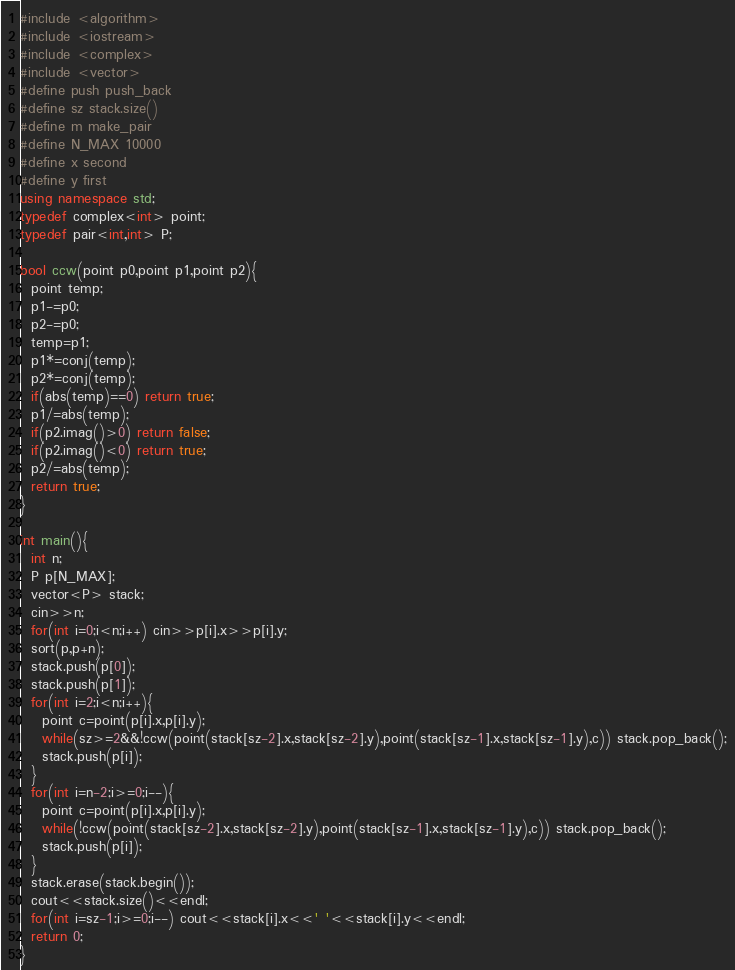Convert code to text. <code><loc_0><loc_0><loc_500><loc_500><_C++_>#include <algorithm>
#include <iostream>
#include <complex>
#include <vector>
#define push push_back
#define sz stack.size()
#define m make_pair
#define N_MAX 10000
#define x second
#define y first
using namespace std;
typedef complex<int> point;
typedef pair<int,int> P;
 
bool ccw(point p0,point p1,point p2){
  point temp;
  p1-=p0;
  p2-=p0;
  temp=p1;
  p1*=conj(temp);
  p2*=conj(temp);
  if(abs(temp)==0) return true;
  p1/=abs(temp);
  if(p2.imag()>0) return false;
  if(p2.imag()<0) return true;
  p2/=abs(temp);
  return true;
}

int main(){
  int n;
  P p[N_MAX];
  vector<P> stack;
  cin>>n;
  for(int i=0;i<n;i++) cin>>p[i].x>>p[i].y;
  sort(p,p+n);
  stack.push(p[0]);
  stack.push(p[1]);
  for(int i=2;i<n;i++){
    point c=point(p[i].x,p[i].y);
    while(sz>=2&&!ccw(point(stack[sz-2].x,stack[sz-2].y),point(stack[sz-1].x,stack[sz-1].y),c)) stack.pop_back();
    stack.push(p[i]);
  }
  for(int i=n-2;i>=0;i--){
    point c=point(p[i].x,p[i].y);
    while(!ccw(point(stack[sz-2].x,stack[sz-2].y),point(stack[sz-1].x,stack[sz-1].y),c)) stack.pop_back();
    stack.push(p[i]);
  }
  stack.erase(stack.begin());
  cout<<stack.size()<<endl;
  for(int i=sz-1;i>=0;i--) cout<<stack[i].x<<' '<<stack[i].y<<endl;
  return 0;
}</code> 